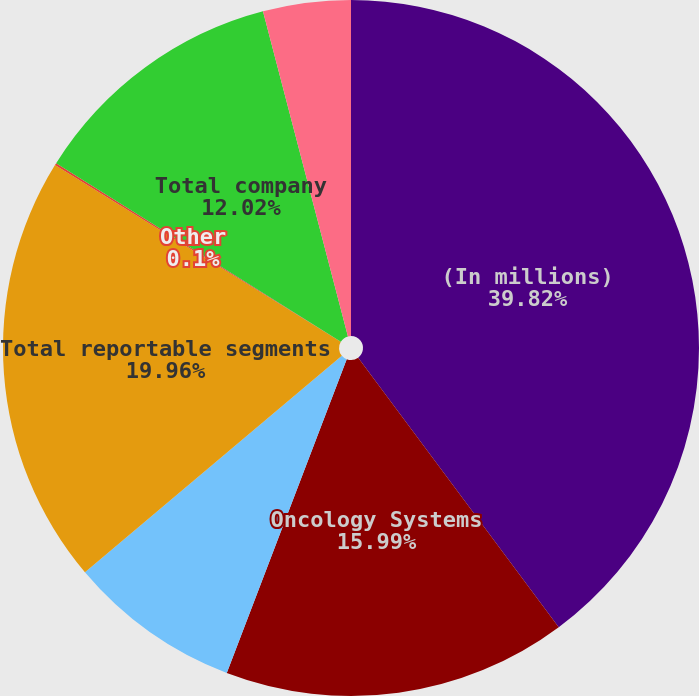Convert chart to OTSL. <chart><loc_0><loc_0><loc_500><loc_500><pie_chart><fcel>(In millions)<fcel>Oncology Systems<fcel>X-ray Products<fcel>Total reportable segments<fcel>Other<fcel>Total company<fcel>Corporate<nl><fcel>39.82%<fcel>15.99%<fcel>8.04%<fcel>19.96%<fcel>0.1%<fcel>12.02%<fcel>4.07%<nl></chart> 